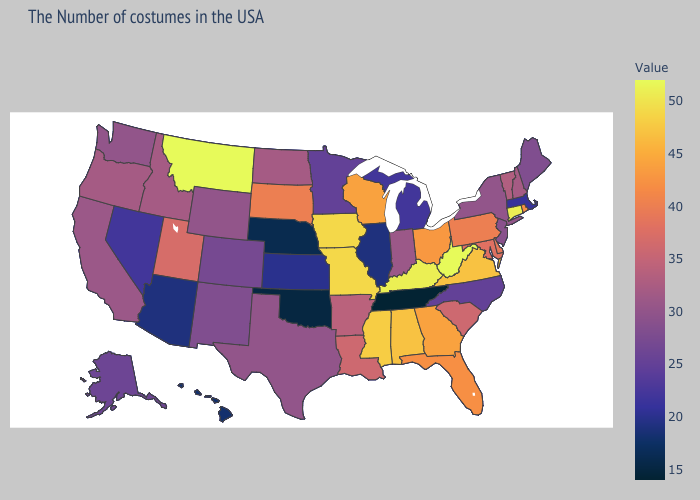Does Colorado have the lowest value in the USA?
Quick response, please. No. Which states have the lowest value in the USA?
Concise answer only. Tennessee. Among the states that border Ohio , does Michigan have the lowest value?
Write a very short answer. Yes. Which states hav the highest value in the Northeast?
Be succinct. Connecticut. Among the states that border Minnesota , does Wisconsin have the lowest value?
Keep it brief. No. 